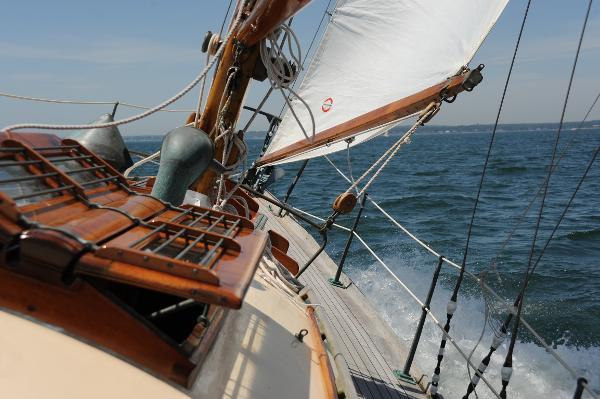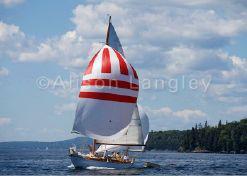The first image is the image on the left, the second image is the image on the right. For the images shown, is this caption "The left and right image contains the same number of sailboats with three open sails." true? Answer yes or no. No. 